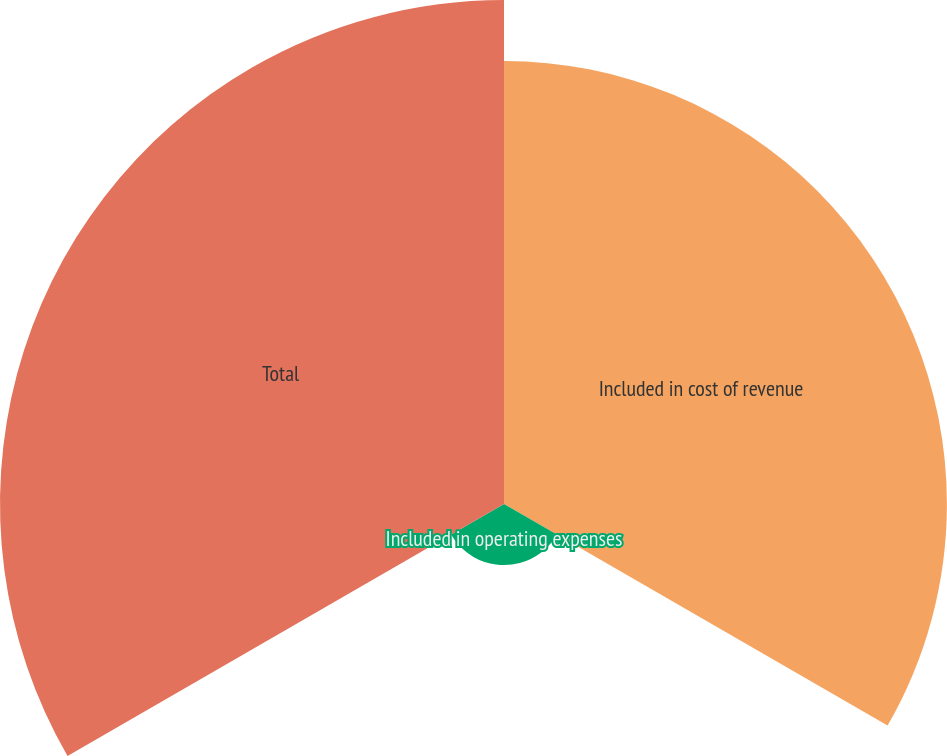Convert chart to OTSL. <chart><loc_0><loc_0><loc_500><loc_500><pie_chart><fcel>Included in cost of revenue<fcel>Included in operating expenses<fcel>Total<nl><fcel>43.94%<fcel>6.06%<fcel>50.0%<nl></chart> 